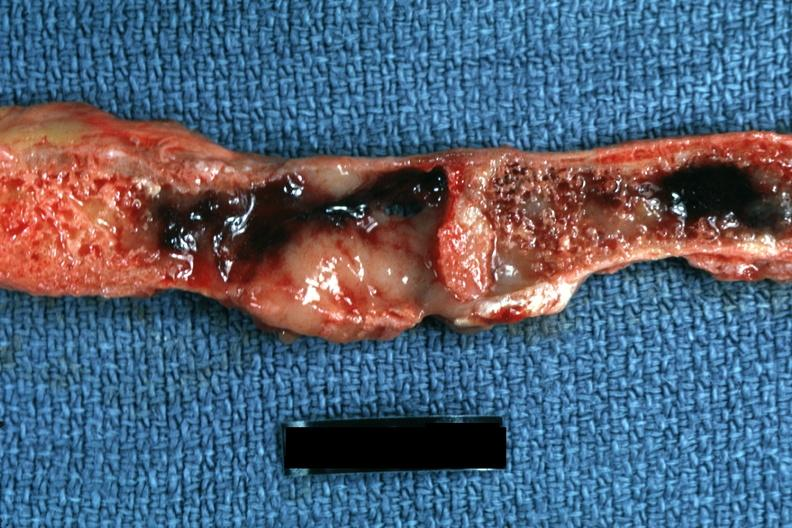what is present?
Answer the question using a single word or phrase. Joints 